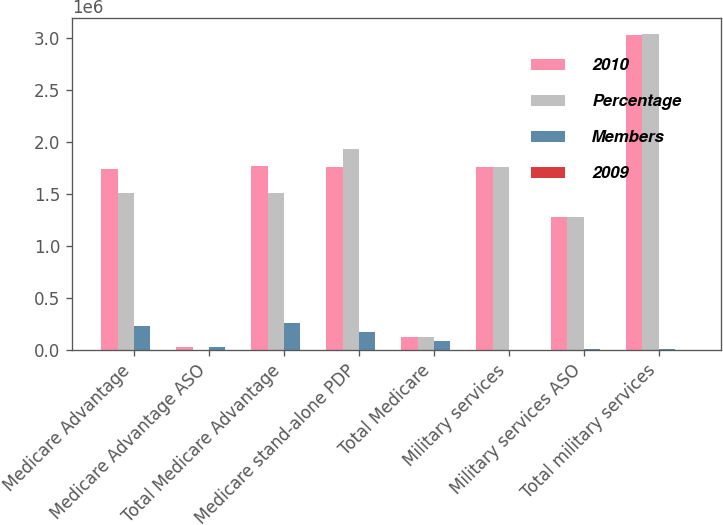Convert chart. <chart><loc_0><loc_0><loc_500><loc_500><stacked_bar_chart><ecel><fcel>Medicare Advantage<fcel>Medicare Advantage ASO<fcel>Total Medicare Advantage<fcel>Medicare stand-alone PDP<fcel>Total Medicare<fcel>Military services<fcel>Military services ASO<fcel>Total military services<nl><fcel>2010<fcel>1.7338e+06<fcel>28200<fcel>1.762e+06<fcel>1.7588e+06<fcel>126750<fcel>1.7552e+06<fcel>1.2726e+06<fcel>3.0278e+06<nl><fcel>Percentage<fcel>1.5085e+06<fcel>0<fcel>1.5085e+06<fcel>1.9279e+06<fcel>126750<fcel>1.756e+06<fcel>1.2784e+06<fcel>3.0344e+06<nl><fcel>Members<fcel>225300<fcel>28200<fcel>253500<fcel>169100<fcel>84400<fcel>800<fcel>5800<fcel>6600<nl><fcel>2009<fcel>14.9<fcel>100<fcel>16.8<fcel>8.8<fcel>2.5<fcel>0<fcel>0.5<fcel>0.2<nl></chart> 